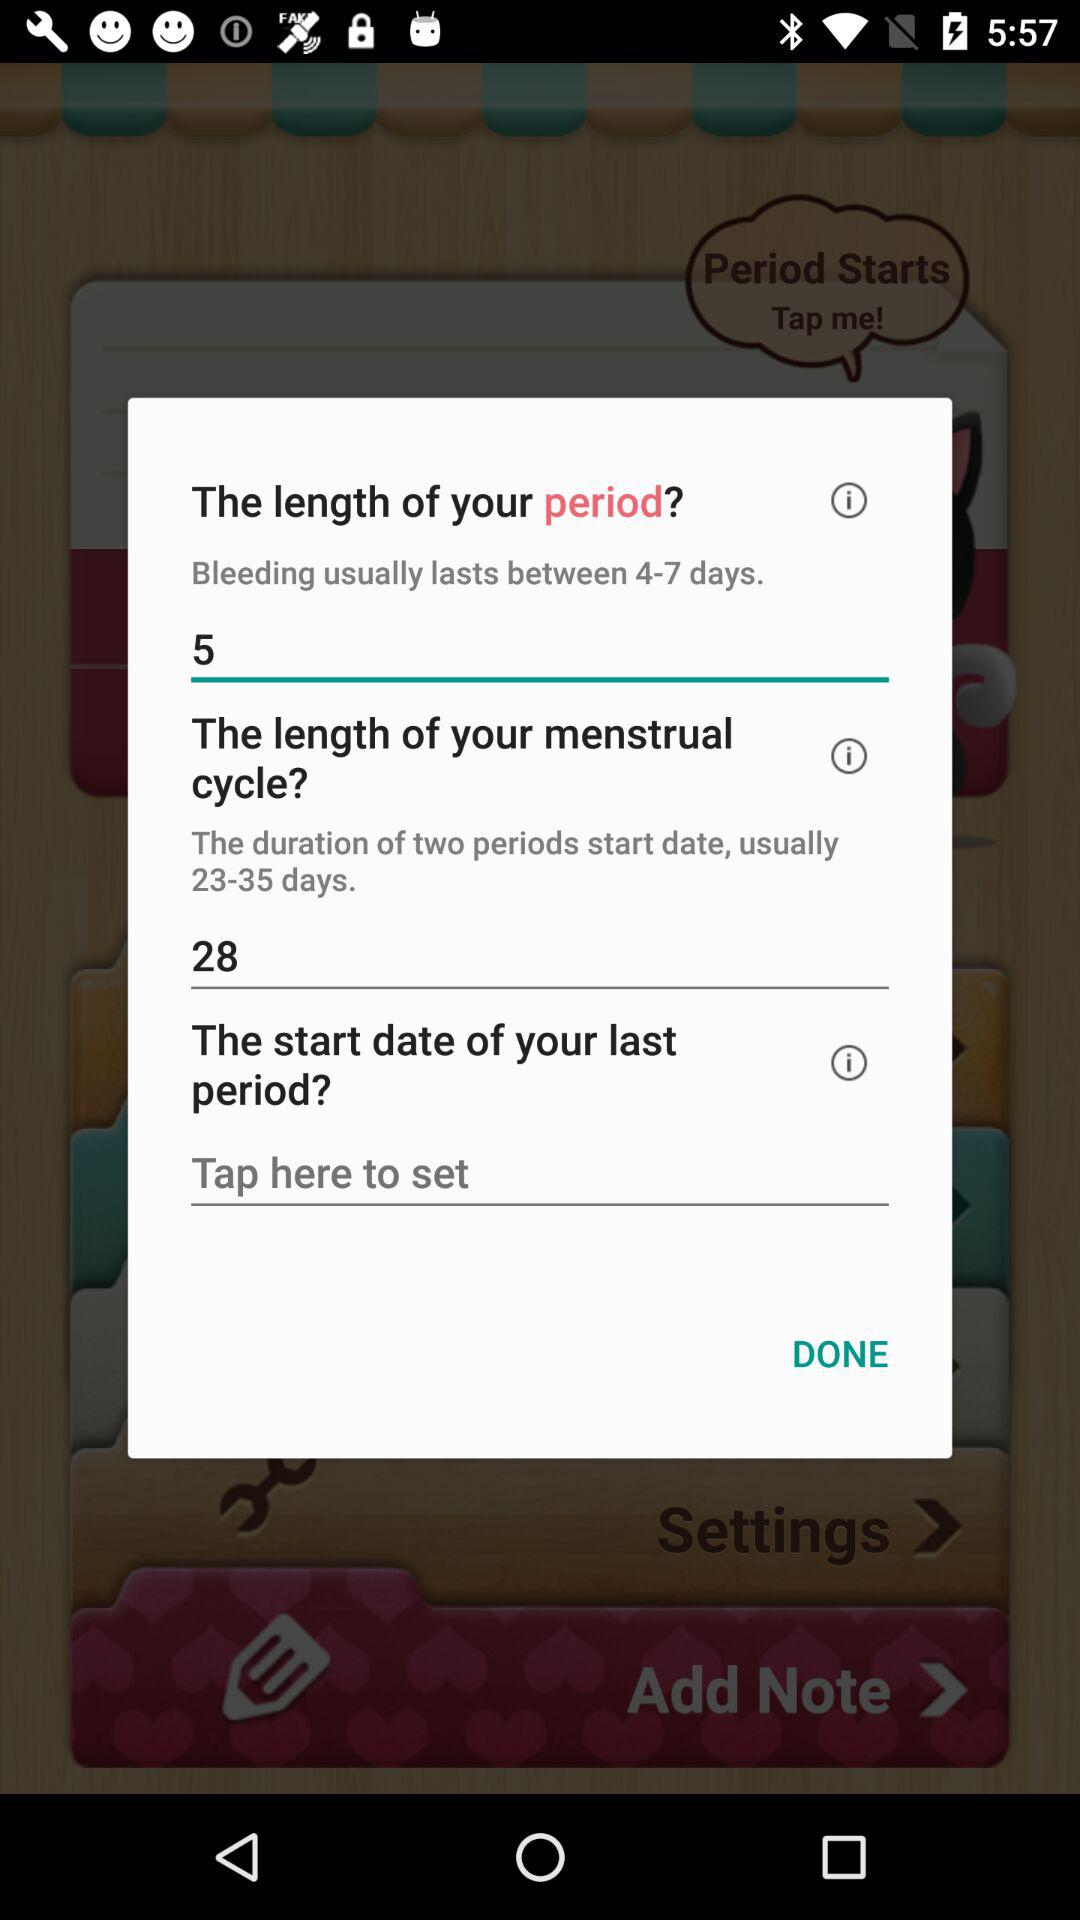What is the time span between two periods' start dates? The time span is 23–35 days. 